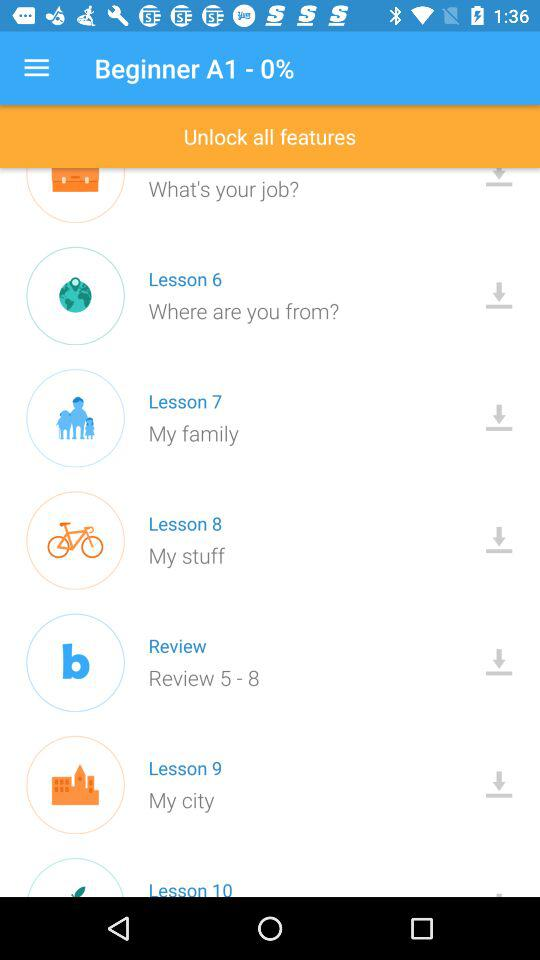Which lesson is "My family"? The lesson is 7. 